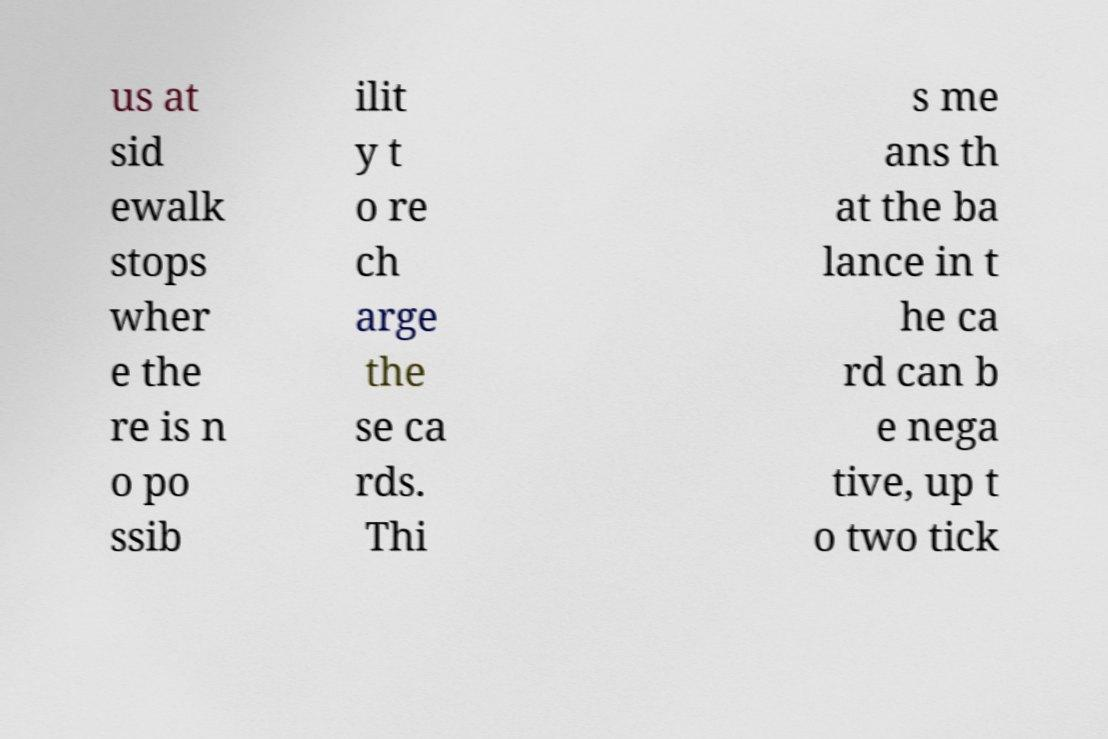There's text embedded in this image that I need extracted. Can you transcribe it verbatim? us at sid ewalk stops wher e the re is n o po ssib ilit y t o re ch arge the se ca rds. Thi s me ans th at the ba lance in t he ca rd can b e nega tive, up t o two tick 